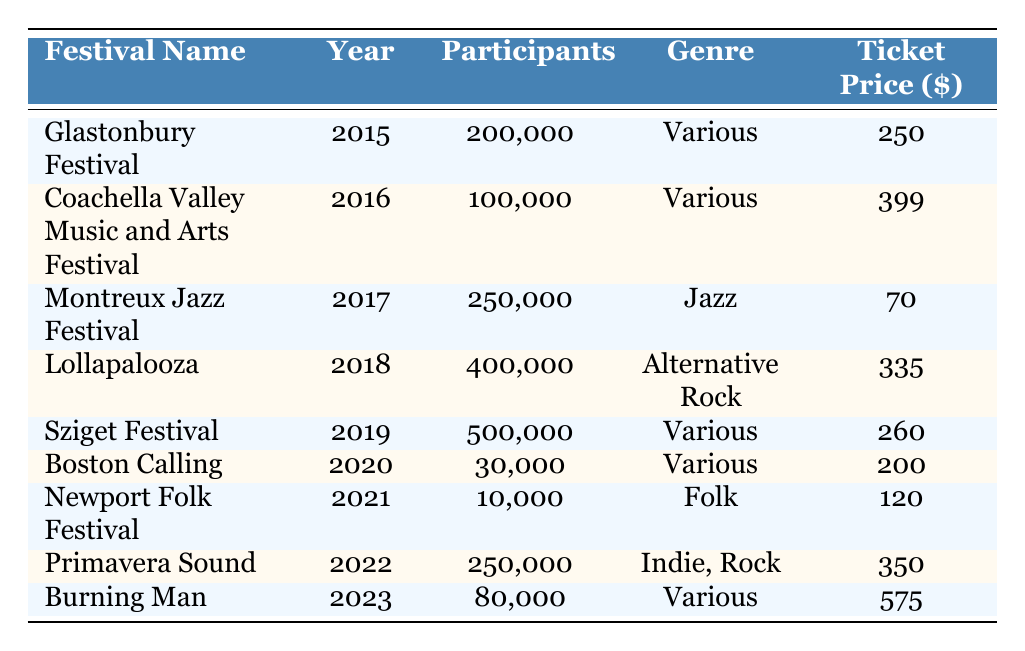What was the ticket price for Glastonbury Festival in 2015? The ticket price is listed directly in the row of Glastonbury Festival for the year 2015, which is 250.
Answer: 250 How many participants attended the Lollapalooza in 2018? The number of participants is mentioned in the row for Lollapalooza in 2018, which is 400,000.
Answer: 400000 What is the average ticket price for all festivals listed? To find the average ticket price, sum the ticket prices: (250 + 399 + 70 + 335 + 260 + 200 + 120 + 350 + 575) = 2260. There are 9 festivals, so the average ticket price is 2260 divided by 9, which equals approximately 251.11.
Answer: 251.11 Did the Newport Folk Festival have more participants than the Boston Calling in 2020? Newport Folk Festival had 10,000 participants, while Boston Calling had 30,000 participants. Since 10,000 is less than 30,000, the answer is no.
Answer: No What was the increase in participation from Montreux Jazz Festival in 2017 to Sziget Festival in 2019? Montreux Jazz Festival had 250,000 participants and Sziget Festival had 500,000 participants. The increase in participation is 500,000 minus 250,000, which equals 250,000.
Answer: 250000 Was the ticket price for Burning Man in 2023 higher than the ticket price for Coachella in 2016? The ticket price for Burning Man in 2023 is 575, and for Coachella in 2016 it is 399. Since 575 is greater than 399, the answer is yes.
Answer: Yes Which festival had the highest number of participants and how many participated? Looking through the table, Sziget Festival in 2019 had the highest number of participants at 500,000.
Answer: Sziget Festival, 500000 How many festivals listed had participants fewer than 100,000? Only Newport Folk Festival in 2021 with 10,000 and Boston Calling in 2020 with 30,000 had fewer than 100,000 participants. Hence, the total is 2 festivals.
Answer: 2 What is the genre of the festival with the highest ticket price? The highest ticket price is 575 for Burning Man. Its genre is Various.
Answer: Various 